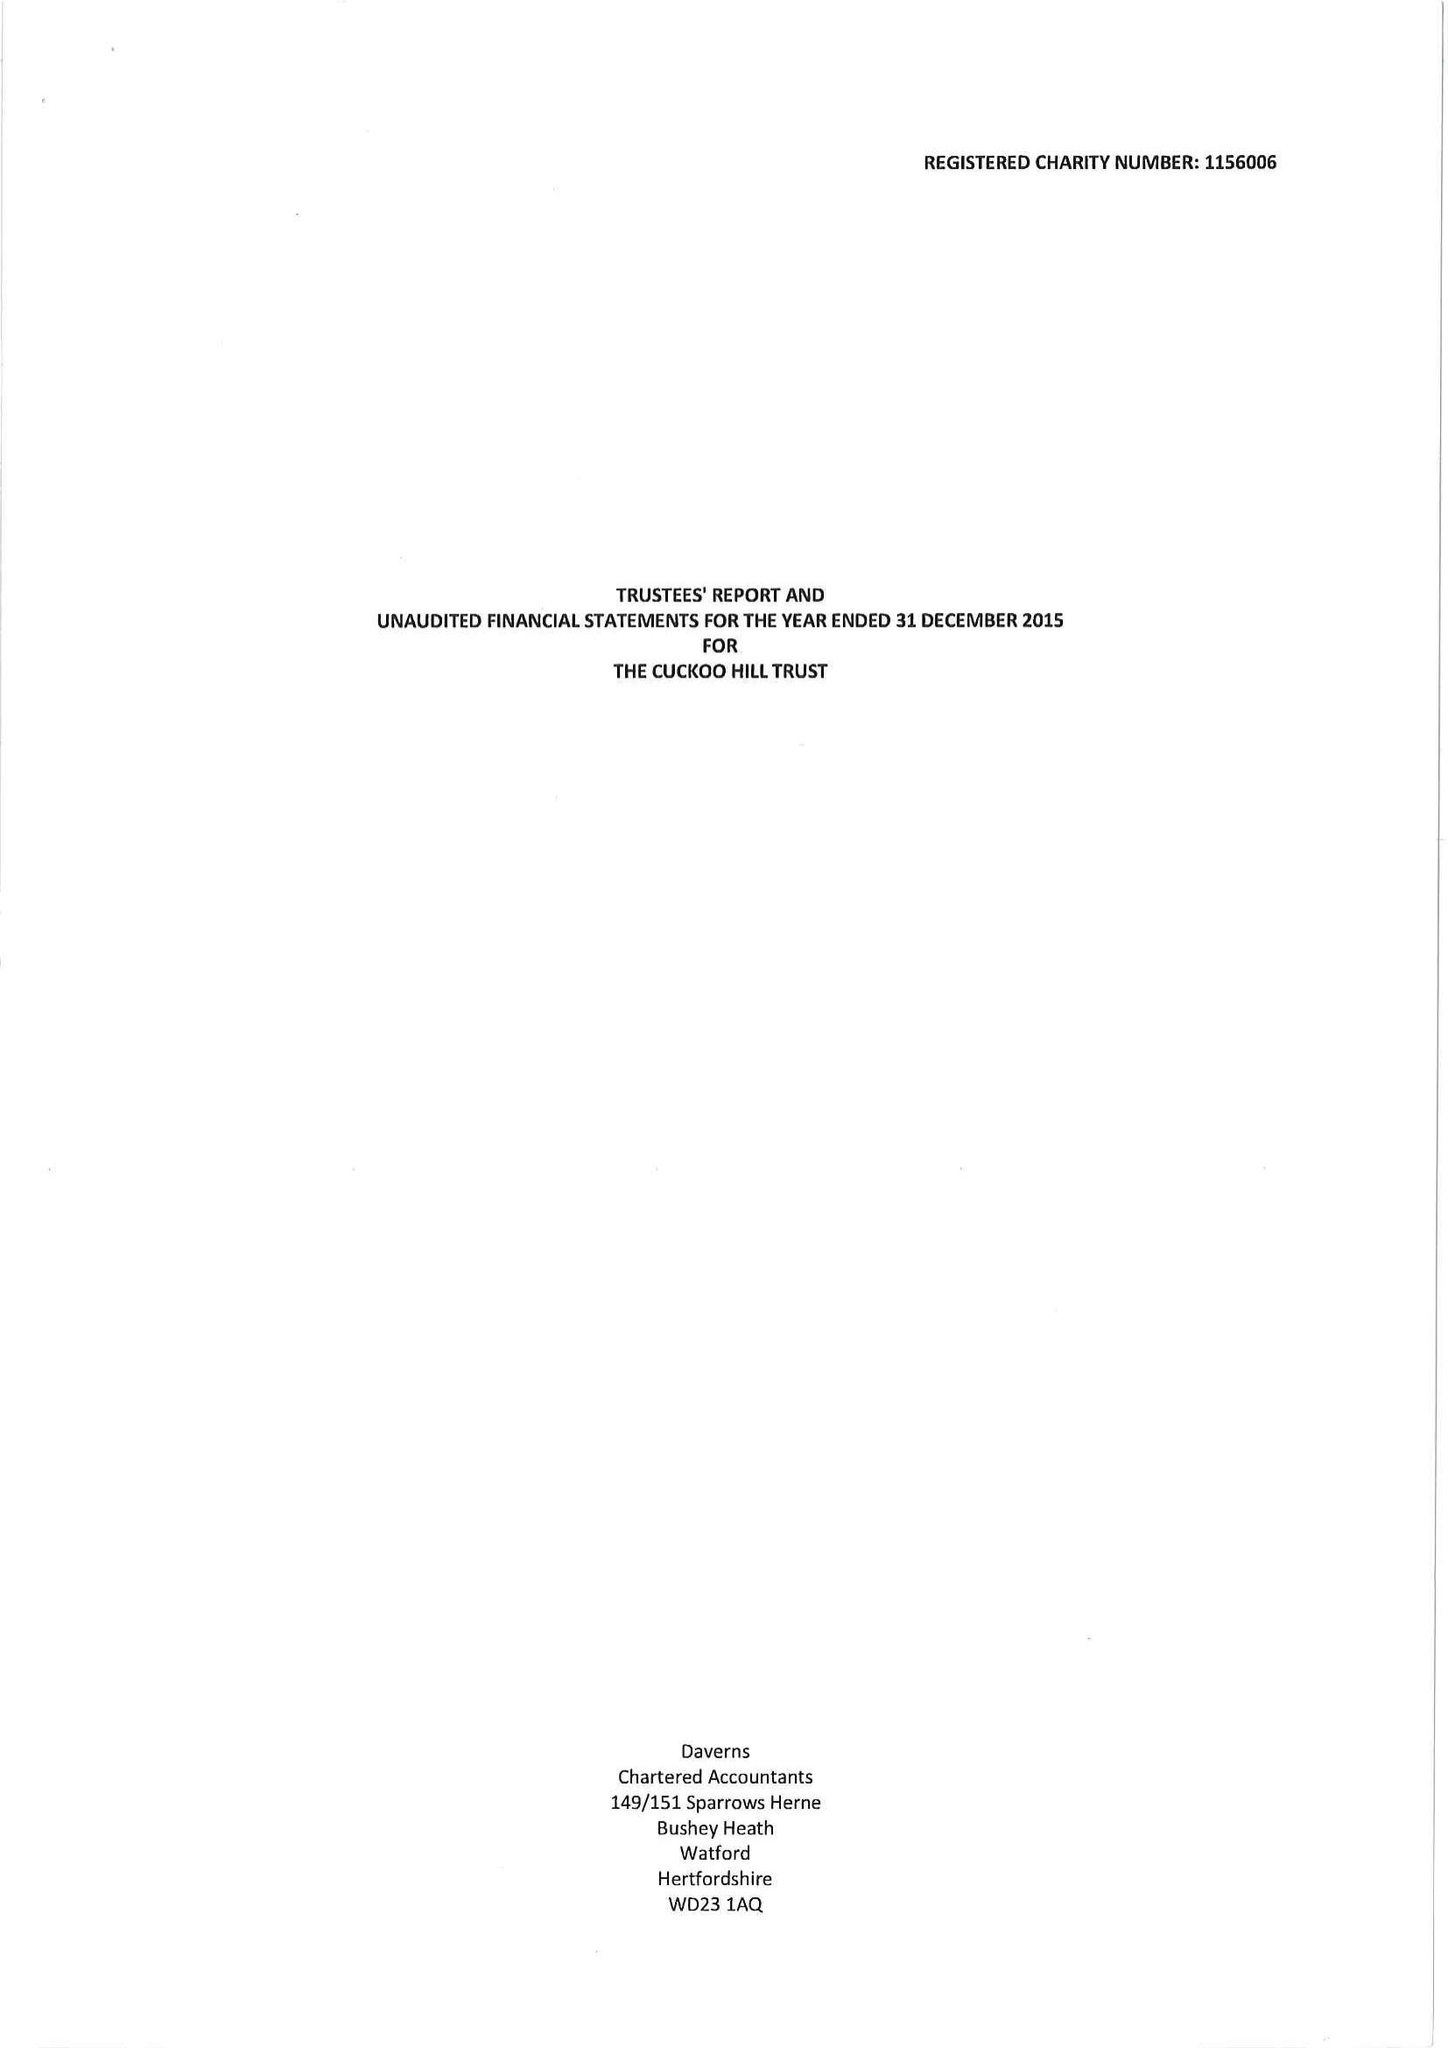What is the value for the charity_number?
Answer the question using a single word or phrase. 1156006 